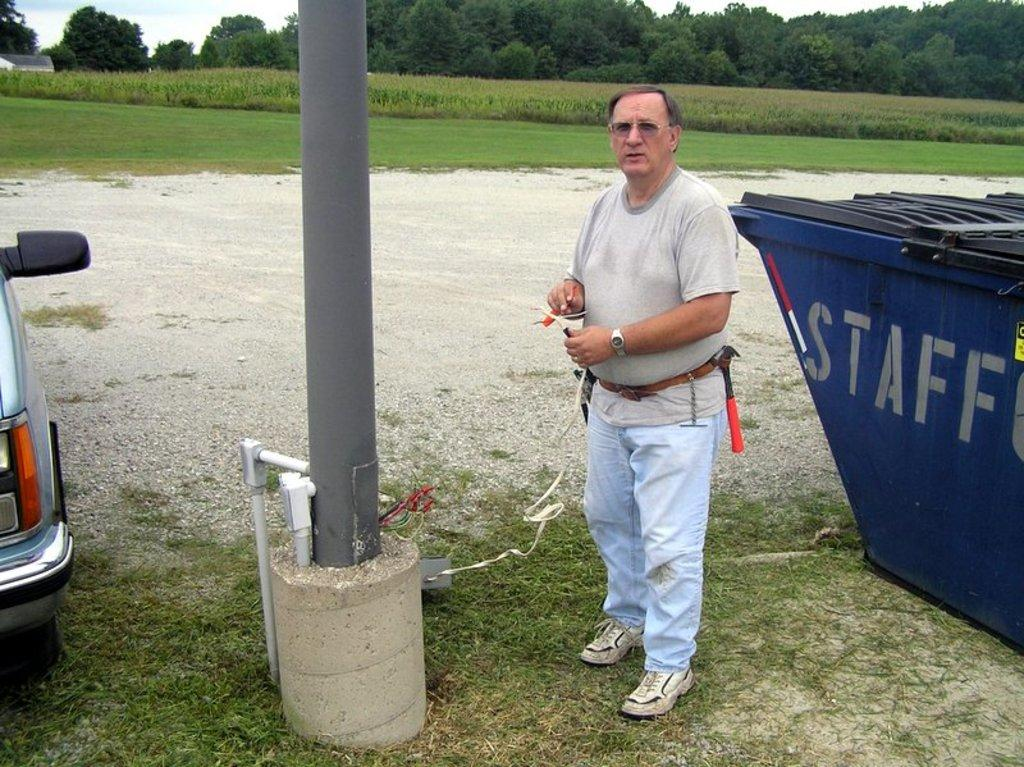Provide a one-sentence caption for the provided image. A man works on a light pole near a large staff garbage bin. 